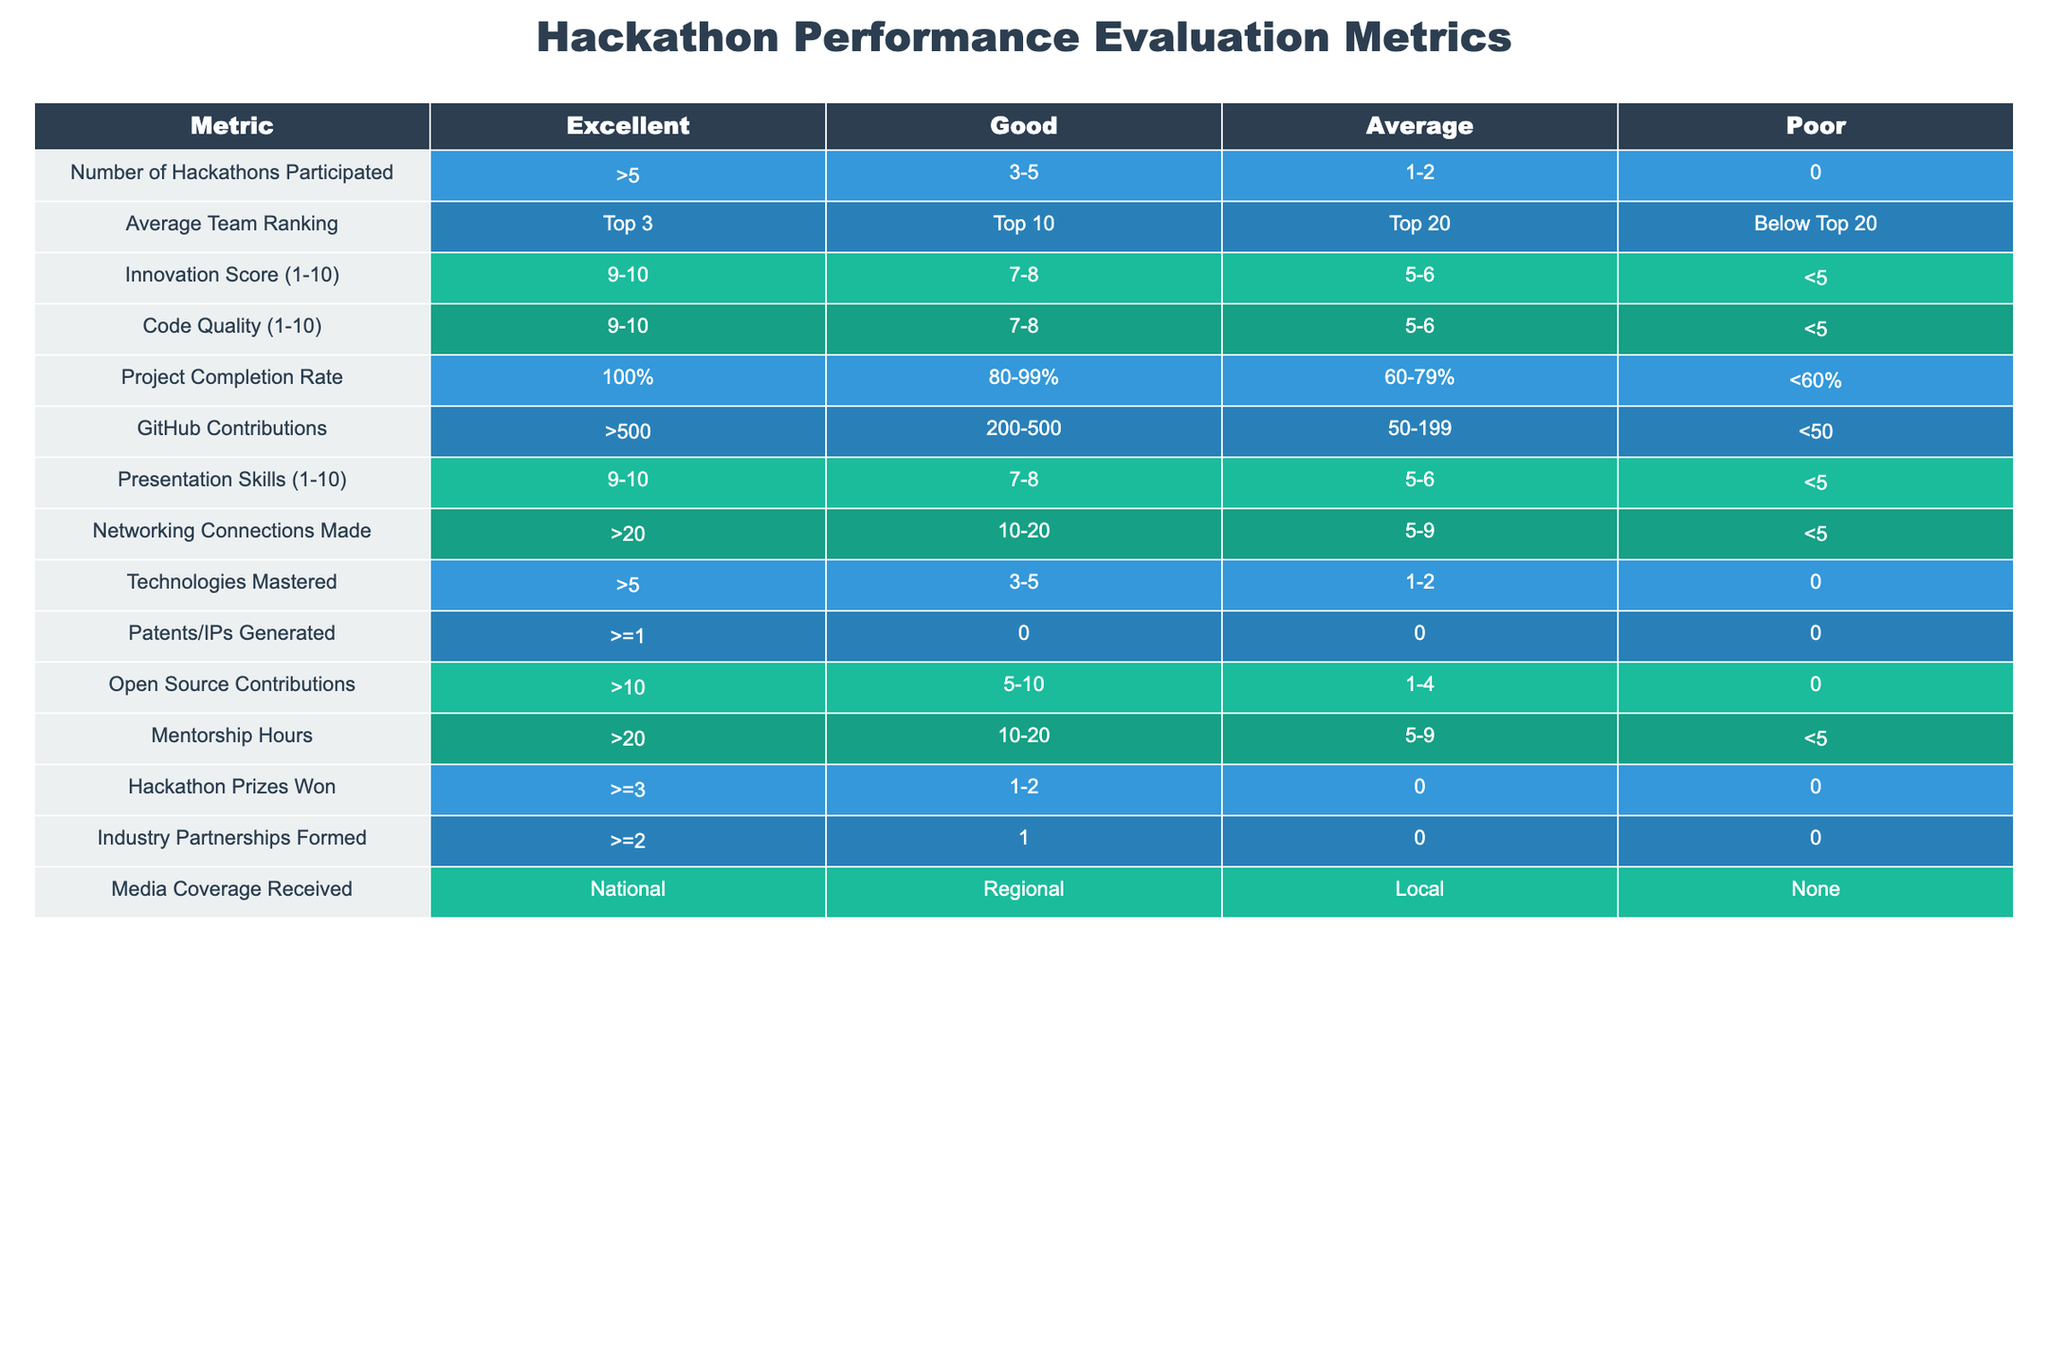What is the minimum number of hackathons a participant must have to be categorized as "Excellent"? According to the table, a participant must have participated in more than 5 hackathons to be categorized as "Excellent."
Answer: More than 5 What is the average team ranking for someone with a "Good" evaluation? A "Good" evaluation corresponds to a team ranking of "Top 10" based on the table's rating criteria.
Answer: Top 10 Can a participant with an average team ranking below Top 20 have an innovation score of 9-10? No, the criteria table indicates that a participant with an average team ranking below Top 20 cannot be classified higher than "Average," thus making a score of 9-10 impossible.
Answer: No What is the total number of GitHub contributions needed to achieve a "Poor" rating? The table specifies that a "Poor" rating is given to participants with fewer than 50 GitHub contributions.
Answer: Less than 50 If a participant has "Excellent" presentation skills and networks more than 20 connections, what could their average team ranking be? If a participant has an excellent presentation skill rating (9-10) and more than 20 networking connections, the average team ranking can vary; it could potentially be "Top 3" or "Top 10," but specific ranking is not determined by these metrics alone.
Answer: Top 3 or Top 10 What percentage of project completion is required to be categorized under "Excellent"? The table shows that to be categorized as "Excellent," the project completion rate must be 100%.
Answer: 100% What total of patents or IPs must a participant have generated to be considered "Excellent"? The evaluation metrics indicate that to achieve an "Excellent" rating, a participant must have generated at least 1 patent or IP.
Answer: At least 1 If a participant wins 2 hackathon prizes, what is their performance level? According to the table, winning 2 hackathon prizes puts a participant in the "Good" category since 1-2 prizes is designated as that level.
Answer: Good How many hours of mentorship must a participant provide to be viewed as "Poor"? The criteria state that less than 5 hours of mentorship results in a "Poor" evaluation.
Answer: Less than 5 